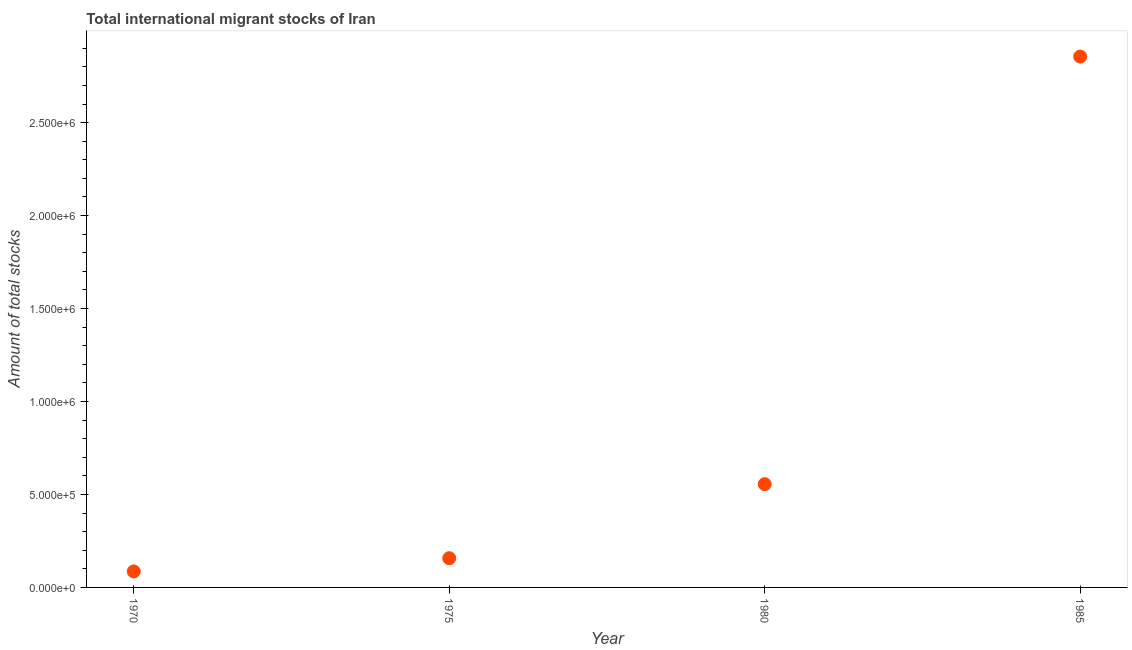What is the total number of international migrant stock in 1975?
Your answer should be compact. 1.57e+05. Across all years, what is the maximum total number of international migrant stock?
Offer a terse response. 2.86e+06. Across all years, what is the minimum total number of international migrant stock?
Offer a very short reply. 8.62e+04. In which year was the total number of international migrant stock maximum?
Your answer should be compact. 1985. In which year was the total number of international migrant stock minimum?
Keep it short and to the point. 1970. What is the sum of the total number of international migrant stock?
Your response must be concise. 3.65e+06. What is the difference between the total number of international migrant stock in 1970 and 1975?
Provide a short and direct response. -7.10e+04. What is the average total number of international migrant stock per year?
Your answer should be very brief. 9.14e+05. What is the median total number of international migrant stock?
Offer a terse response. 3.56e+05. What is the ratio of the total number of international migrant stock in 1970 to that in 1975?
Offer a terse response. 0.55. What is the difference between the highest and the second highest total number of international migrant stock?
Your answer should be compact. 2.30e+06. What is the difference between the highest and the lowest total number of international migrant stock?
Make the answer very short. 2.77e+06. In how many years, is the total number of international migrant stock greater than the average total number of international migrant stock taken over all years?
Your response must be concise. 1. Does the graph contain grids?
Offer a terse response. No. What is the title of the graph?
Give a very brief answer. Total international migrant stocks of Iran. What is the label or title of the X-axis?
Ensure brevity in your answer.  Year. What is the label or title of the Y-axis?
Provide a succinct answer. Amount of total stocks. What is the Amount of total stocks in 1970?
Your response must be concise. 8.62e+04. What is the Amount of total stocks in 1975?
Give a very brief answer. 1.57e+05. What is the Amount of total stocks in 1980?
Your answer should be very brief. 5.55e+05. What is the Amount of total stocks in 1985?
Give a very brief answer. 2.86e+06. What is the difference between the Amount of total stocks in 1970 and 1975?
Your answer should be very brief. -7.10e+04. What is the difference between the Amount of total stocks in 1970 and 1980?
Your answer should be compact. -4.69e+05. What is the difference between the Amount of total stocks in 1970 and 1985?
Ensure brevity in your answer.  -2.77e+06. What is the difference between the Amount of total stocks in 1975 and 1980?
Provide a succinct answer. -3.98e+05. What is the difference between the Amount of total stocks in 1975 and 1985?
Ensure brevity in your answer.  -2.70e+06. What is the difference between the Amount of total stocks in 1980 and 1985?
Keep it short and to the point. -2.30e+06. What is the ratio of the Amount of total stocks in 1970 to that in 1975?
Provide a succinct answer. 0.55. What is the ratio of the Amount of total stocks in 1970 to that in 1980?
Give a very brief answer. 0.15. What is the ratio of the Amount of total stocks in 1975 to that in 1980?
Ensure brevity in your answer.  0.28. What is the ratio of the Amount of total stocks in 1975 to that in 1985?
Your answer should be very brief. 0.06. What is the ratio of the Amount of total stocks in 1980 to that in 1985?
Offer a terse response. 0.2. 